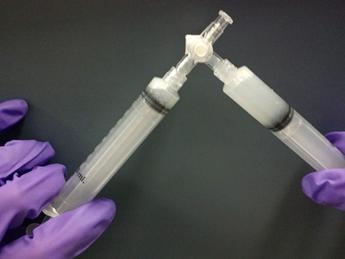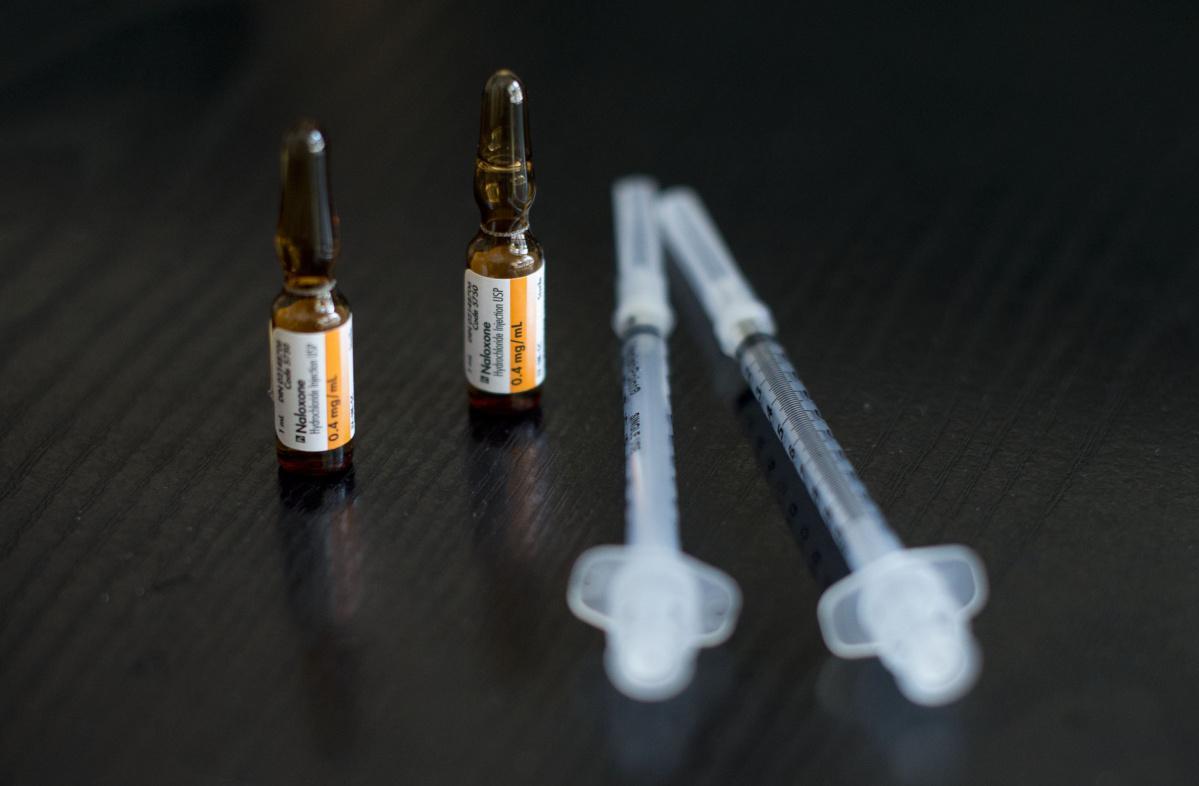The first image is the image on the left, the second image is the image on the right. Considering the images on both sides, is "There is a white wire attached to all of the syringes in one of the images, and no wires in the other image." valid? Answer yes or no. No. The first image is the image on the left, the second image is the image on the right. Evaluate the accuracy of this statement regarding the images: "there are syringes with tubing on them". Is it true? Answer yes or no. No. 